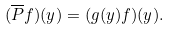Convert formula to latex. <formula><loc_0><loc_0><loc_500><loc_500>( \overline { P } f ) ( y ) = ( g ( y ) f ) ( y ) .</formula> 